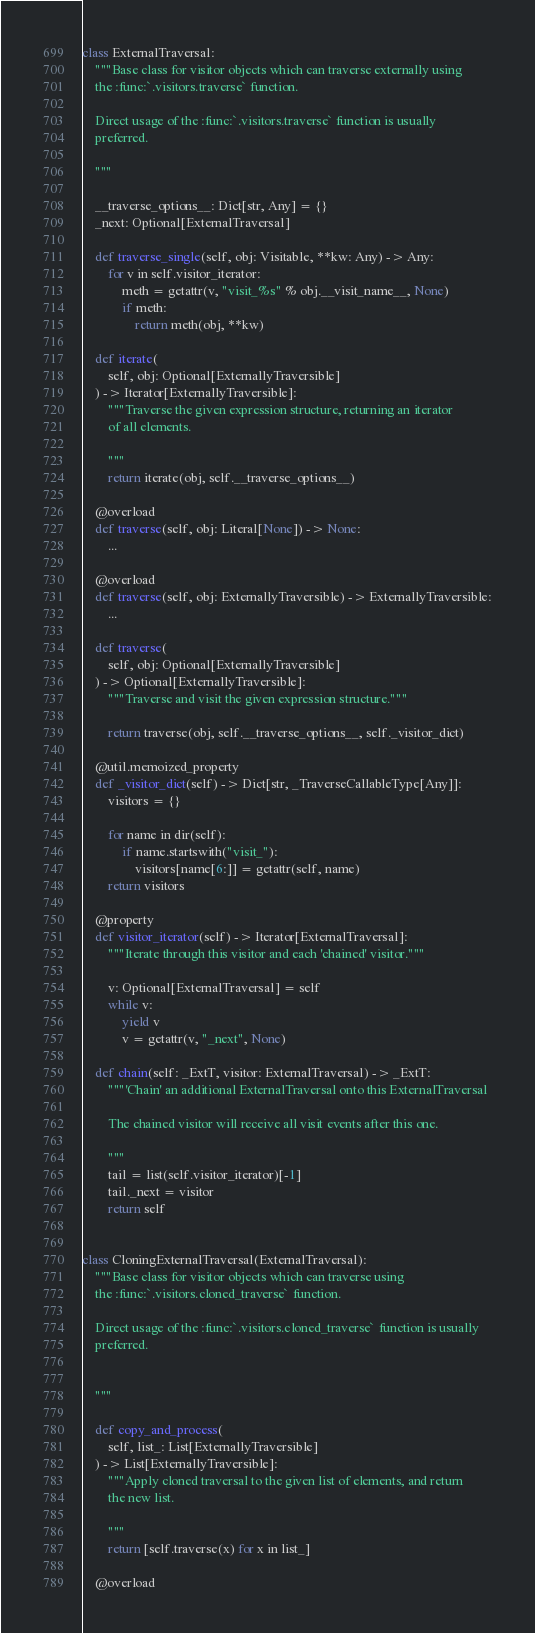<code> <loc_0><loc_0><loc_500><loc_500><_Python_>class ExternalTraversal:
    """Base class for visitor objects which can traverse externally using
    the :func:`.visitors.traverse` function.

    Direct usage of the :func:`.visitors.traverse` function is usually
    preferred.

    """

    __traverse_options__: Dict[str, Any] = {}
    _next: Optional[ExternalTraversal]

    def traverse_single(self, obj: Visitable, **kw: Any) -> Any:
        for v in self.visitor_iterator:
            meth = getattr(v, "visit_%s" % obj.__visit_name__, None)
            if meth:
                return meth(obj, **kw)

    def iterate(
        self, obj: Optional[ExternallyTraversible]
    ) -> Iterator[ExternallyTraversible]:
        """Traverse the given expression structure, returning an iterator
        of all elements.

        """
        return iterate(obj, self.__traverse_options__)

    @overload
    def traverse(self, obj: Literal[None]) -> None:
        ...

    @overload
    def traverse(self, obj: ExternallyTraversible) -> ExternallyTraversible:
        ...

    def traverse(
        self, obj: Optional[ExternallyTraversible]
    ) -> Optional[ExternallyTraversible]:
        """Traverse and visit the given expression structure."""

        return traverse(obj, self.__traverse_options__, self._visitor_dict)

    @util.memoized_property
    def _visitor_dict(self) -> Dict[str, _TraverseCallableType[Any]]:
        visitors = {}

        for name in dir(self):
            if name.startswith("visit_"):
                visitors[name[6:]] = getattr(self, name)
        return visitors

    @property
    def visitor_iterator(self) -> Iterator[ExternalTraversal]:
        """Iterate through this visitor and each 'chained' visitor."""

        v: Optional[ExternalTraversal] = self
        while v:
            yield v
            v = getattr(v, "_next", None)

    def chain(self: _ExtT, visitor: ExternalTraversal) -> _ExtT:
        """'Chain' an additional ExternalTraversal onto this ExternalTraversal

        The chained visitor will receive all visit events after this one.

        """
        tail = list(self.visitor_iterator)[-1]
        tail._next = visitor
        return self


class CloningExternalTraversal(ExternalTraversal):
    """Base class for visitor objects which can traverse using
    the :func:`.visitors.cloned_traverse` function.

    Direct usage of the :func:`.visitors.cloned_traverse` function is usually
    preferred.


    """

    def copy_and_process(
        self, list_: List[ExternallyTraversible]
    ) -> List[ExternallyTraversible]:
        """Apply cloned traversal to the given list of elements, and return
        the new list.

        """
        return [self.traverse(x) for x in list_]

    @overload</code> 